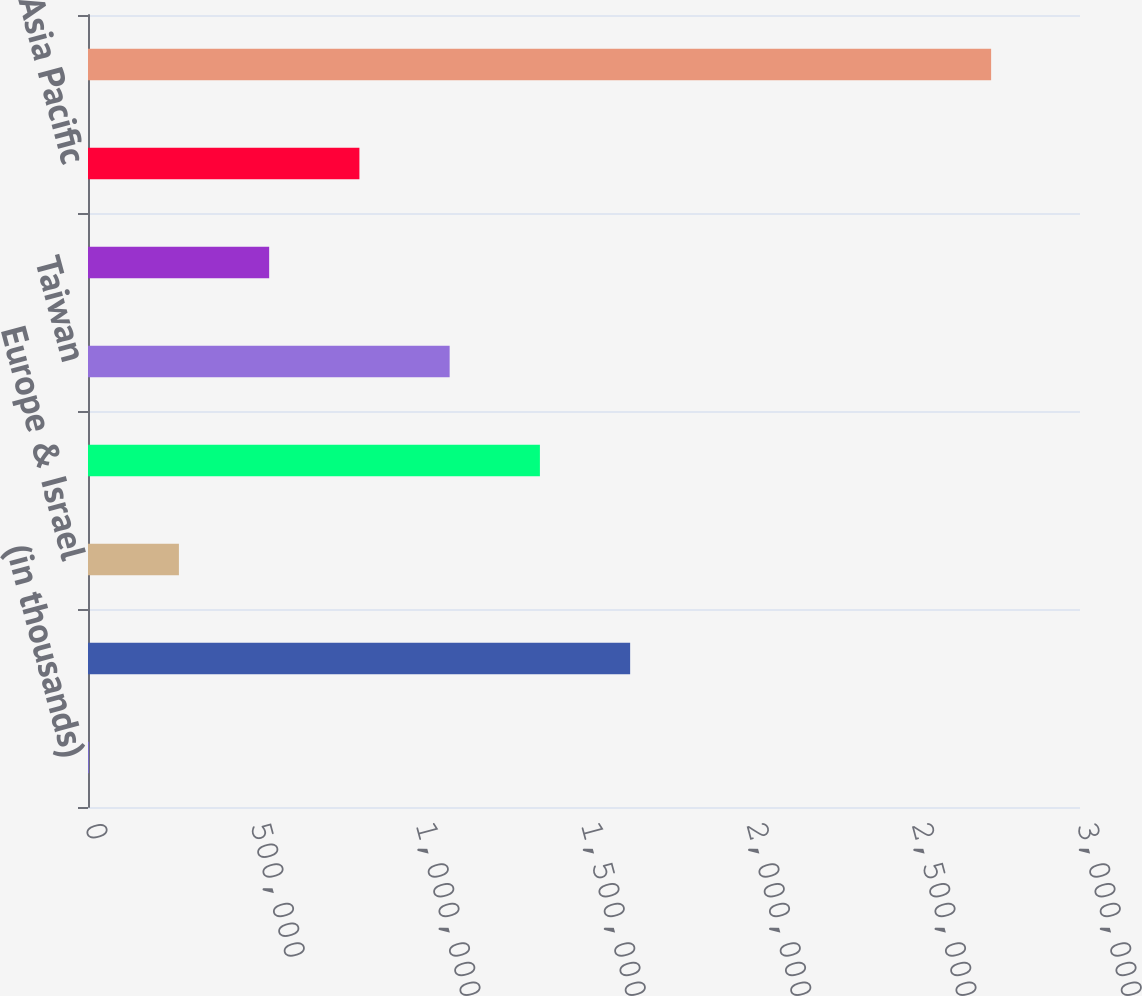Convert chart. <chart><loc_0><loc_0><loc_500><loc_500><bar_chart><fcel>(in thousands)<fcel>United States<fcel>Europe & Israel<fcel>Japan<fcel>Taiwan<fcel>Korea<fcel>Asia Pacific<fcel>Total<nl><fcel>2007<fcel>1.63954e+06<fcel>274929<fcel>1.36662e+06<fcel>1.0937e+06<fcel>547851<fcel>820774<fcel>2.73123e+06<nl></chart> 